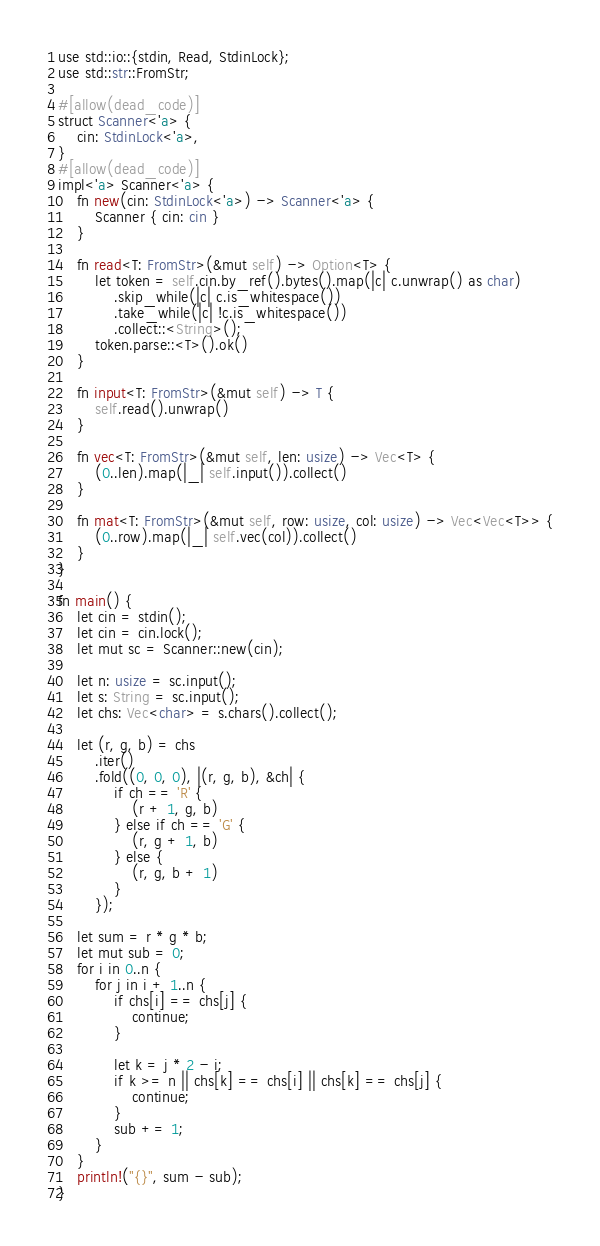Convert code to text. <code><loc_0><loc_0><loc_500><loc_500><_Rust_>use std::io::{stdin, Read, StdinLock};
use std::str::FromStr;

#[allow(dead_code)]
struct Scanner<'a> {
    cin: StdinLock<'a>,
}
#[allow(dead_code)]
impl<'a> Scanner<'a> {
    fn new(cin: StdinLock<'a>) -> Scanner<'a> {
        Scanner { cin: cin }
    }

    fn read<T: FromStr>(&mut self) -> Option<T> {
        let token = self.cin.by_ref().bytes().map(|c| c.unwrap() as char)
            .skip_while(|c| c.is_whitespace())
            .take_while(|c| !c.is_whitespace())
            .collect::<String>();
        token.parse::<T>().ok()
    }

    fn input<T: FromStr>(&mut self) -> T {
        self.read().unwrap()
    }

    fn vec<T: FromStr>(&mut self, len: usize) -> Vec<T> {
        (0..len).map(|_| self.input()).collect()
    }

    fn mat<T: FromStr>(&mut self, row: usize, col: usize) -> Vec<Vec<T>> {
        (0..row).map(|_| self.vec(col)).collect()
    }
}

fn main() {
    let cin = stdin();
    let cin = cin.lock();
    let mut sc = Scanner::new(cin);

    let n: usize = sc.input();
    let s: String = sc.input();
    let chs: Vec<char> = s.chars().collect();

    let (r, g, b) = chs
        .iter()
        .fold((0, 0, 0), |(r, g, b), &ch| {
            if ch == 'R' {
                (r + 1, g, b)
            } else if ch == 'G' {
                (r, g + 1, b)
            } else {
                (r, g, b + 1)
            }
        });

    let sum = r * g * b;
    let mut sub = 0;
    for i in 0..n {
        for j in i + 1..n {
            if chs[i] == chs[j] {
                continue;
            }

            let k = j * 2 - i;
            if k >= n || chs[k] == chs[i] || chs[k] == chs[j] {
                continue;
            }
            sub += 1;
        }
    }
    println!("{}", sum - sub);
}
</code> 